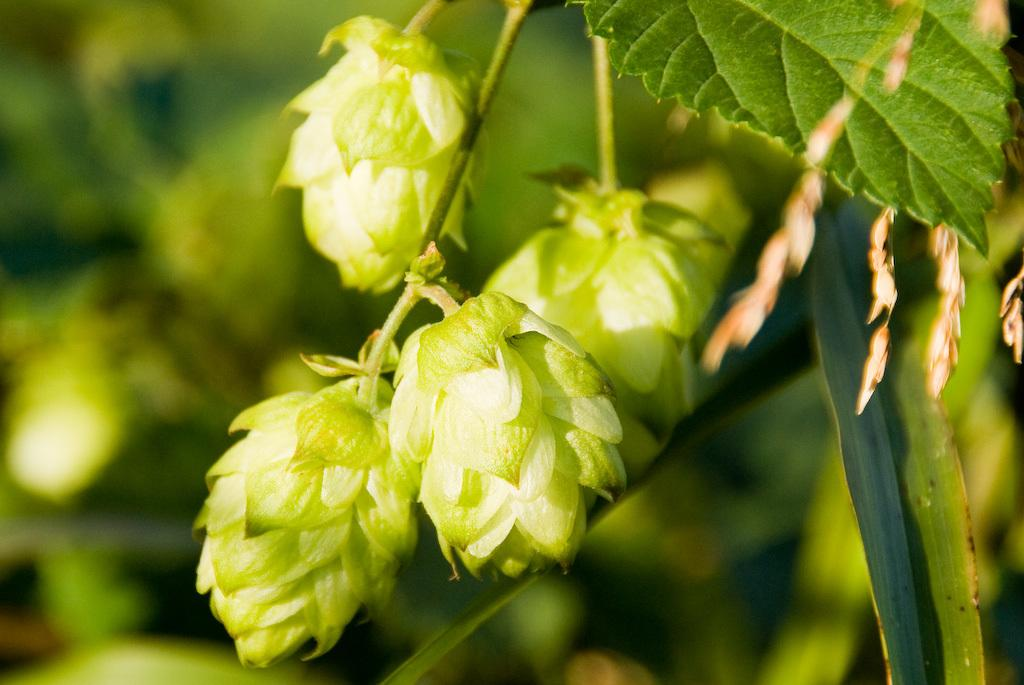What type of plants can be seen in the image? There are flowers in the image. What color are the flowers and the leaf in the image? The flowers and the leaf are green. Can you describe the background of the image? The background of the image is blurry. Where is the throne located in the image? There is no throne present in the image. How hot is the temperature in the image? The image does not provide information about the temperature, so it cannot be determined. 